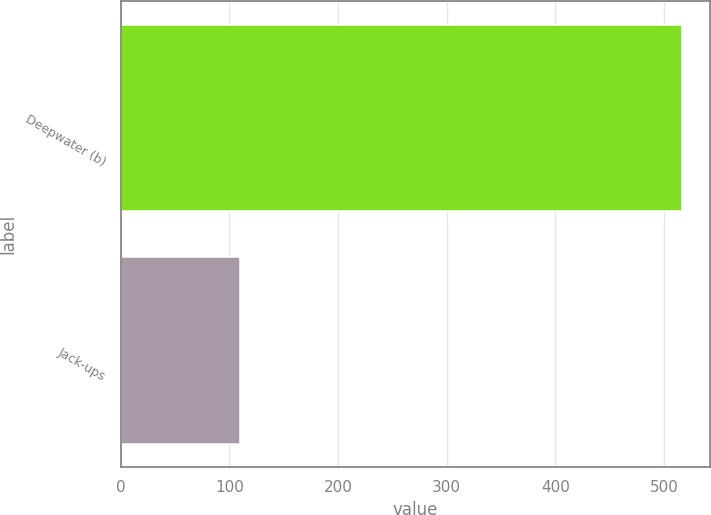<chart> <loc_0><loc_0><loc_500><loc_500><bar_chart><fcel>Deepwater (b)<fcel>Jack-ups<nl><fcel>516<fcel>110<nl></chart> 